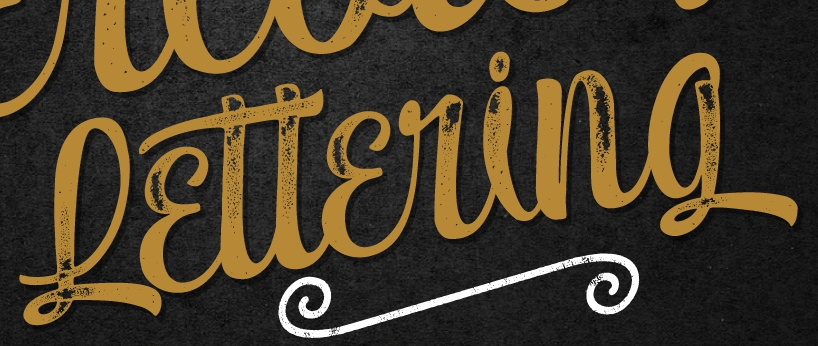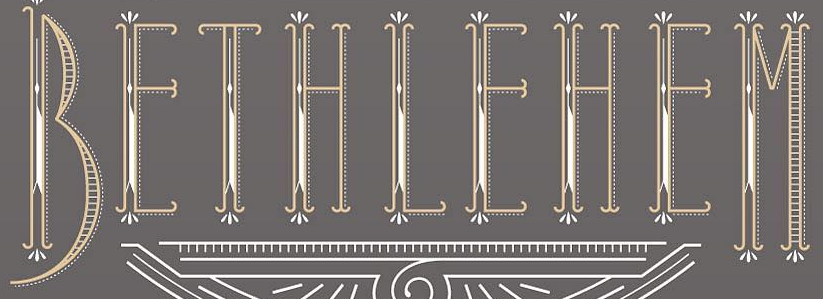Transcribe the words shown in these images in order, separated by a semicolon. Lɛttɛring; BEIHIEHEM 